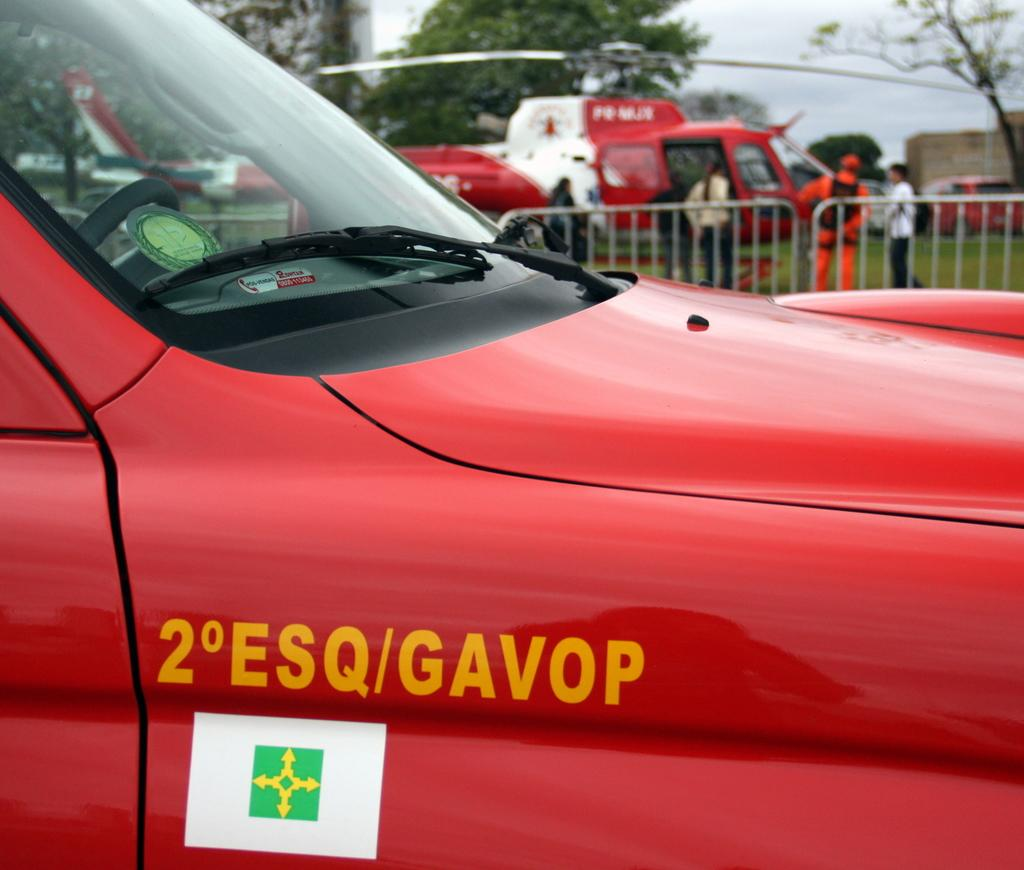<image>
Create a compact narrative representing the image presented. A red truck has 2 ESQ/GAVOP on the side in yellow. 